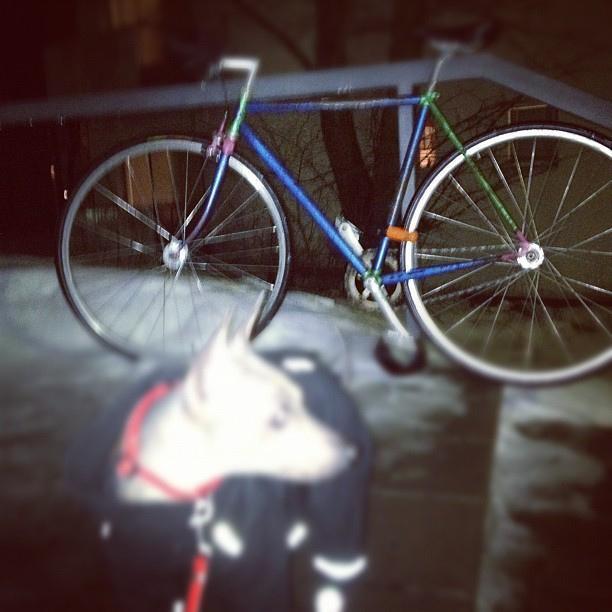How many wheels does this vehicle have?
Give a very brief answer. 2. How many bicycles can you see?
Give a very brief answer. 2. How many handles does the black oven have?
Give a very brief answer. 0. 